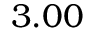Convert formula to latex. <formula><loc_0><loc_0><loc_500><loc_500>3 . 0 0</formula> 